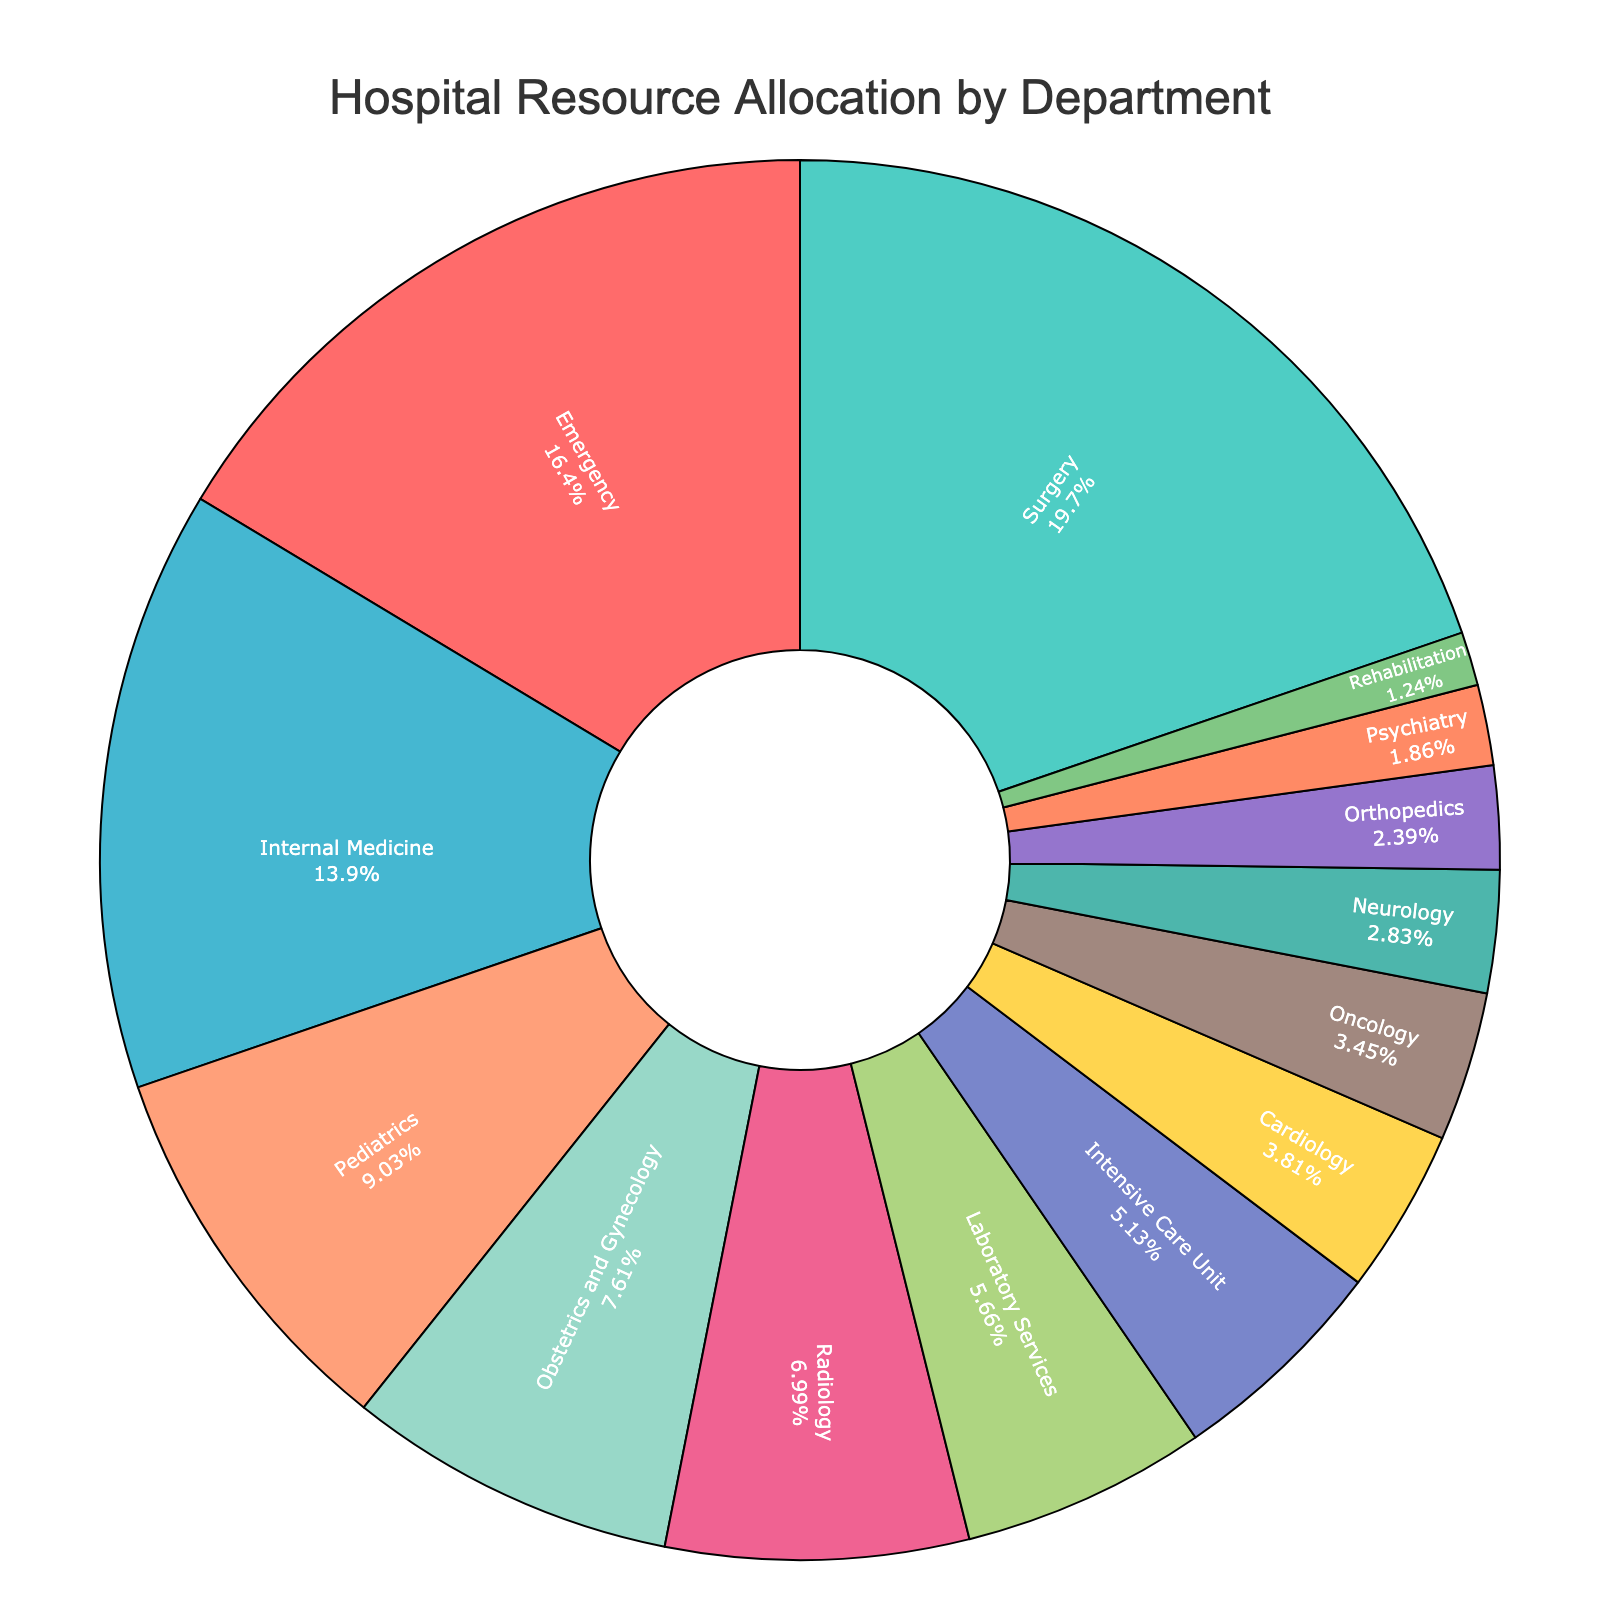What percentage of the budget is allocated to the department with the highest allocation? The highest budget allocation is represented by the largest section of the pie chart. Inspecting the figure, the Surgery department has the highest allocation percentage at 22.3%.
Answer: 22.3% Which two departments have the smallest budget allocations, and what are their percentages? To find the two departments with the smallest budget allocations, look for the two smallest sections of the pie chart. The Rehabilitation department has an allocation of 1.4%, and the Psychiatry department has an allocation of 2.1%.
Answer: Rehabilitation: 1.4%, Psychiatry: 2.1% How much more budget is allocated to the Emergency department compared to the Cardiology department? Locate the sections of the pie chart for the Emergency and Cardiology departments. Emergency has 18.5%, and Cardiology has 4.3%. The difference is 18.5% - 4.3% = 14.2%.
Answer: 14.2% What is the combined budget allocation percentage of the Surgery and Internal Medicine departments? Find the percentages for Surgery and Internal Medicine. Surgery has 22.3%, and Internal Medicine has 15.7%. The combined percentage is 22.3% + 15.7% = 38%.
Answer: 38% Which department has a budget allocation closest to 10%, and what is that department's exact allocation? Identify the department whose section is closest to the 10% division. Pediatrics has an allocation of 10.2%, which is closest to 10%.
Answer: Pediatrics: 10.2% How does the budget allocation for Radiology compare to that for Laboratory Services? Find the sections for Radiology and Laboratory Services. Radiology has 7.9%, and Laboratory Services has 6.4%. Radiology's budget allocation is higher by 7.9% - 6.4% = 1.5%.
Answer: Radiology is higher by 1.5% What is the total budget allocation percentage for the three departments with the lowest allocation percentages? Locate the three smallest sections. Rehabilitation (1.4%), Psychiatry (2.1%), and Orthopedics (2.7%). Sum them: 1.4% + 2.1% + 2.7% = 6.2%.
Answer: 6.2% What is the approximate share of budget for departments with allocations above 10%? Identify sections with percentages greater than 10%: Emergency (18.5%), Surgery (22.3%), and Internal Medicine (15.7%). Sum them: 18.5% + 22.3% + 15.7% = 56.5%.
Answer: 56.5% Rank the top three departments by budget allocation and state their percentages. Locate and list the top three departments based on the section sizes. Surgery (22.3%), Emergency (18.5%), and Internal Medicine (15.7%).
Answer: Surgery: 22.3%, Emergency: 18.5%, Internal Medicine: 15.7% What is the difference in budget allocation between Pediatrics and Obstetrics and Gynecology? Find the sections for Pediatrics and Obstetrics and Gynecology. Pediatrics has 10.2%, and Obstetrics and Gynecology has 8.6%. The difference is 10.2% - 8.6% = 1.6%.
Answer: 1.6% 